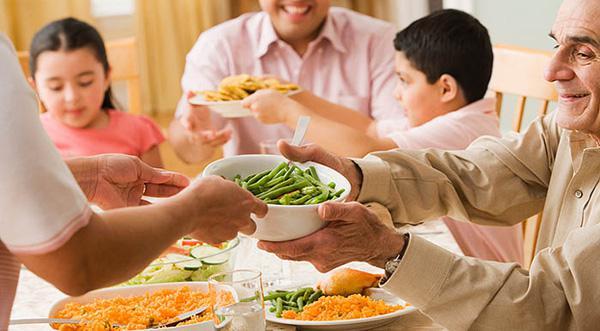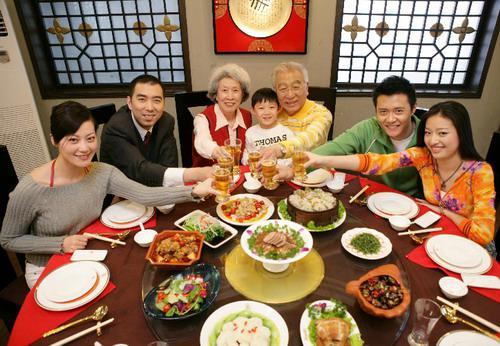The first image is the image on the left, the second image is the image on the right. Assess this claim about the two images: "People are holding chopsticks in both images.". Correct or not? Answer yes or no. No. The first image is the image on the left, the second image is the image on the right. Evaluate the accuracy of this statement regarding the images: "In one of the images, four people are about to grab food from one plate, each using chop sticks.". Is it true? Answer yes or no. No. 